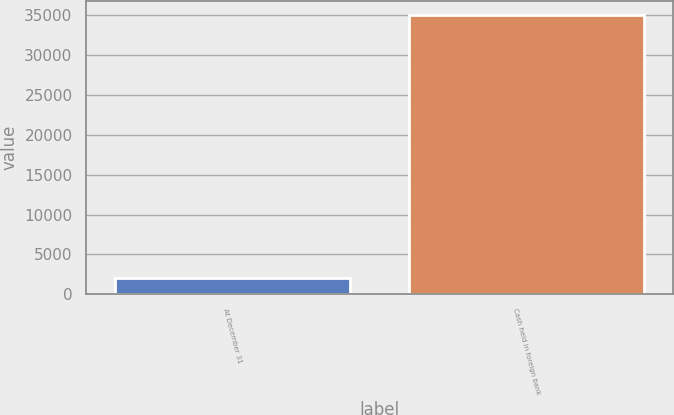<chart> <loc_0><loc_0><loc_500><loc_500><bar_chart><fcel>At December 31<fcel>Cash held in foreign bank<nl><fcel>2014<fcel>35065<nl></chart> 